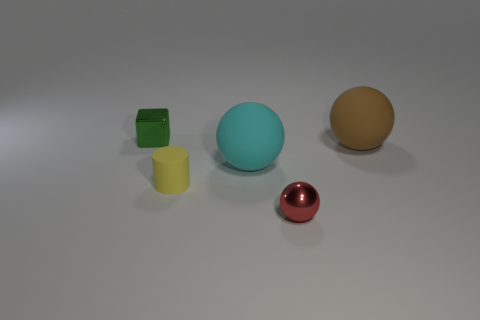How many objects are either big balls or metallic objects that are on the right side of the large cyan sphere?
Offer a terse response. 3. Is the color of the cube the same as the small metallic ball?
Provide a short and direct response. No. Is there a tiny block that has the same material as the small yellow cylinder?
Provide a short and direct response. No. What is the color of the small thing that is the same shape as the large brown matte object?
Offer a terse response. Red. Are the tiny ball and the thing on the left side of the small matte cylinder made of the same material?
Make the answer very short. Yes. There is a thing that is on the right side of the metal thing that is in front of the green thing; what shape is it?
Offer a very short reply. Sphere. Does the thing that is to the left of the cylinder have the same size as the yellow rubber thing?
Your answer should be very brief. Yes. How many other things are there of the same shape as the red metal thing?
Give a very brief answer. 2. Do the sphere that is in front of the small cylinder and the tiny cylinder have the same color?
Your answer should be very brief. No. Are there any tiny spheres of the same color as the block?
Ensure brevity in your answer.  No. 